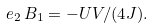<formula> <loc_0><loc_0><loc_500><loc_500>e _ { 2 } \, B _ { 1 } = - U V / ( 4 J ) .</formula> 